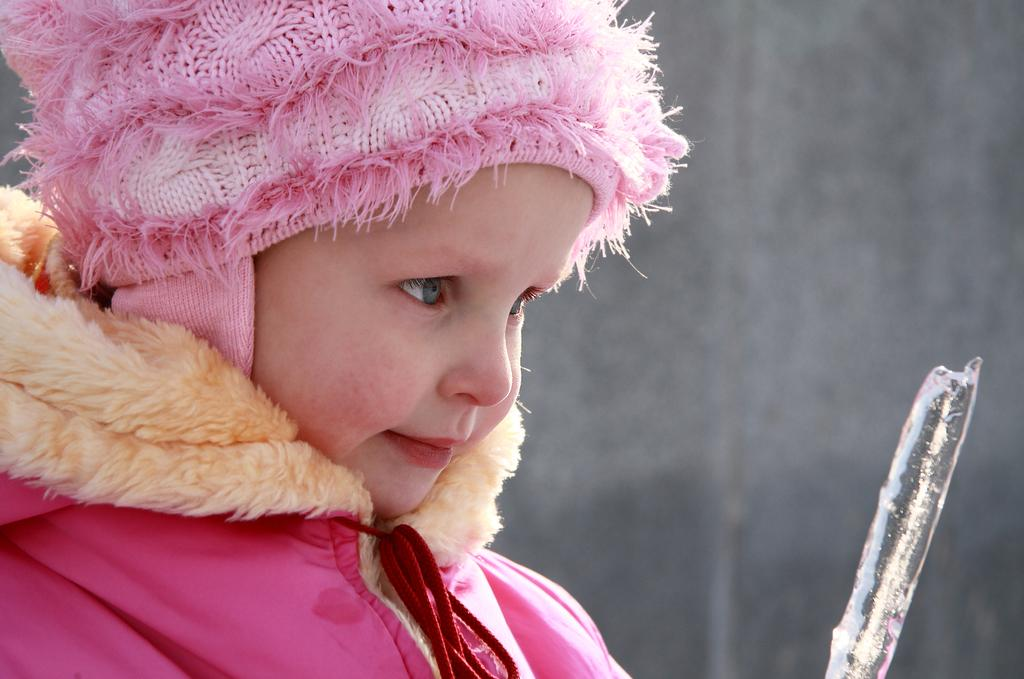Who is present in the image? There is a girl in the image. What can be seen on the right side of the image? There is an object on the right side of the image. What is the background of the image? There is a wall in the image. What type of milk is the girl drinking from the jar in the image? There is no milk or jar present in the image. 